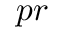<formula> <loc_0><loc_0><loc_500><loc_500>p r</formula> 